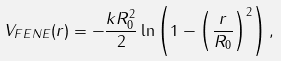Convert formula to latex. <formula><loc_0><loc_0><loc_500><loc_500>V _ { F E N E } ( r ) = - \frac { k R _ { 0 } ^ { 2 } } { 2 } \ln \left ( 1 - \left ( \frac { r } { R _ { 0 } } \right ) ^ { 2 } \right ) ,</formula> 